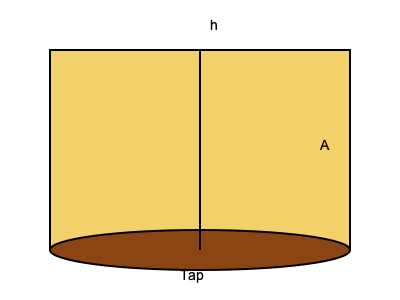At your tailgate party, you've set up a keg of beer with a height (h) of 0.8 meters and a cross-sectional area (A) of 0.2 m². If the tap at the bottom has a cross-sectional area of 0.0001 m², what is the initial velocity of the beer flowing out of the tap? Assume ideal conditions and use $g = 9.8$ m/s². To solve this problem, we'll use Torricelli's theorem, which is derived from Bernoulli's principle in fluid dynamics. The steps are as follows:

1) Torricelli's theorem states that the velocity of a liquid flowing out of an opening is given by:

   $v = \sqrt{2gh}$

   Where:
   $v$ is the velocity of the liquid
   $g$ is the acceleration due to gravity
   $h$ is the height of the liquid above the opening

2) We're given:
   $h = 0.8$ m
   $g = 9.8$ m/s²

3) Plugging these values into the equation:

   $v = \sqrt{2 \cdot 9.8 \cdot 0.8}$

4) Simplify:
   $v = \sqrt{15.68}$

5) Calculate:
   $v \approx 3.96$ m/s

Therefore, the initial velocity of the beer flowing out of the tap is approximately 3.96 m/s.

Note: The cross-sectional areas of the keg and tap weren't needed for this calculation, but they would be relevant if we were calculating the flow rate or how quickly the keg would empty.
Answer: 3.96 m/s 